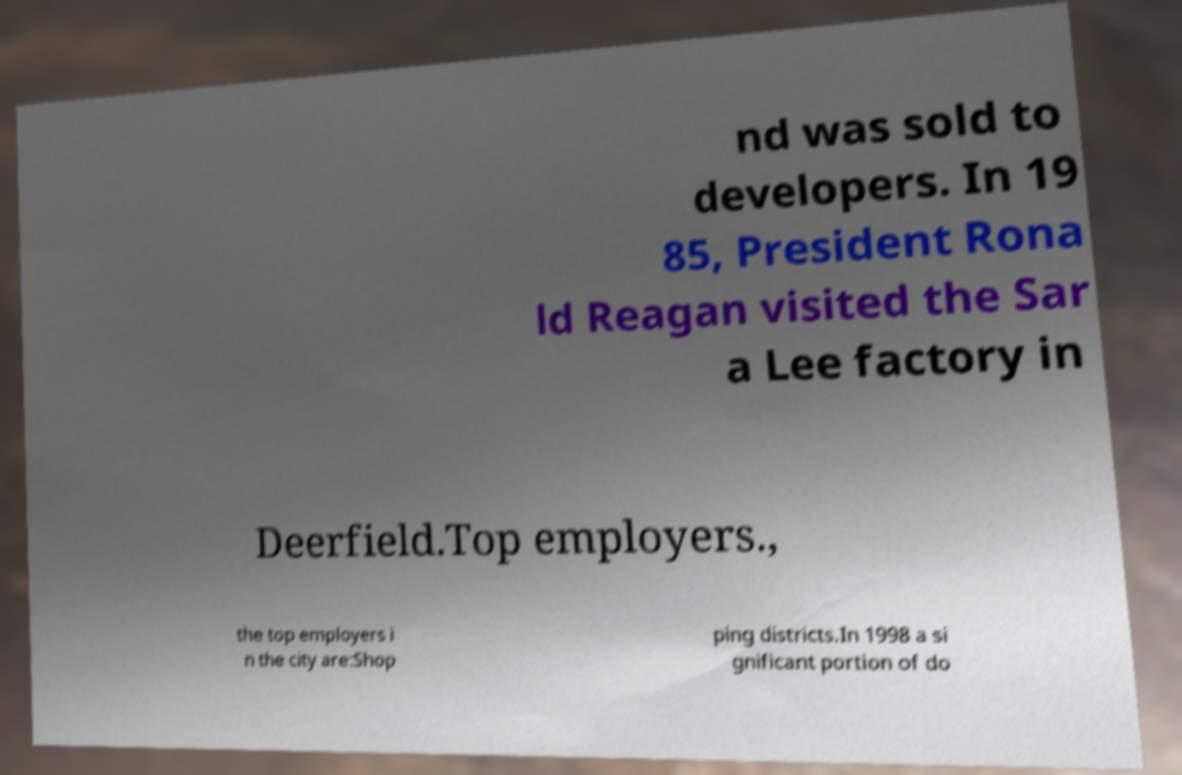Could you assist in decoding the text presented in this image and type it out clearly? nd was sold to developers. In 19 85, President Rona ld Reagan visited the Sar a Lee factory in Deerfield.Top employers., the top employers i n the city are:Shop ping districts.In 1998 a si gnificant portion of do 